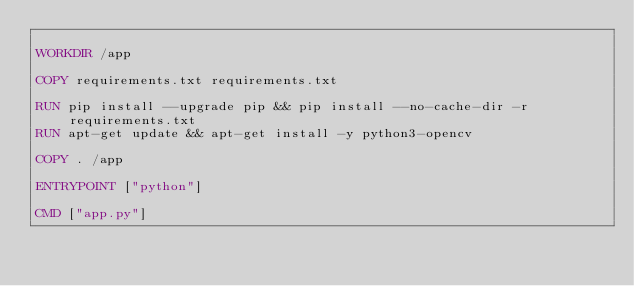<code> <loc_0><loc_0><loc_500><loc_500><_Dockerfile_>
WORKDIR /app

COPY requirements.txt requirements.txt 

RUN pip install --upgrade pip && pip install --no-cache-dir -r requirements.txt
RUN apt-get update && apt-get install -y python3-opencv

COPY . /app 

ENTRYPOINT ["python"]

CMD ["app.py"]


</code> 